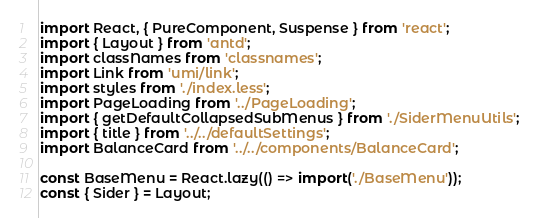Convert code to text. <code><loc_0><loc_0><loc_500><loc_500><_JavaScript_>import React, { PureComponent, Suspense } from 'react';
import { Layout } from 'antd';
import classNames from 'classnames';
import Link from 'umi/link';
import styles from './index.less';
import PageLoading from '../PageLoading';
import { getDefaultCollapsedSubMenus } from './SiderMenuUtils';
import { title } from '../../defaultSettings';
import BalanceCard from '../../components/BalanceCard';

const BaseMenu = React.lazy(() => import('./BaseMenu'));
const { Sider } = Layout;
</code> 